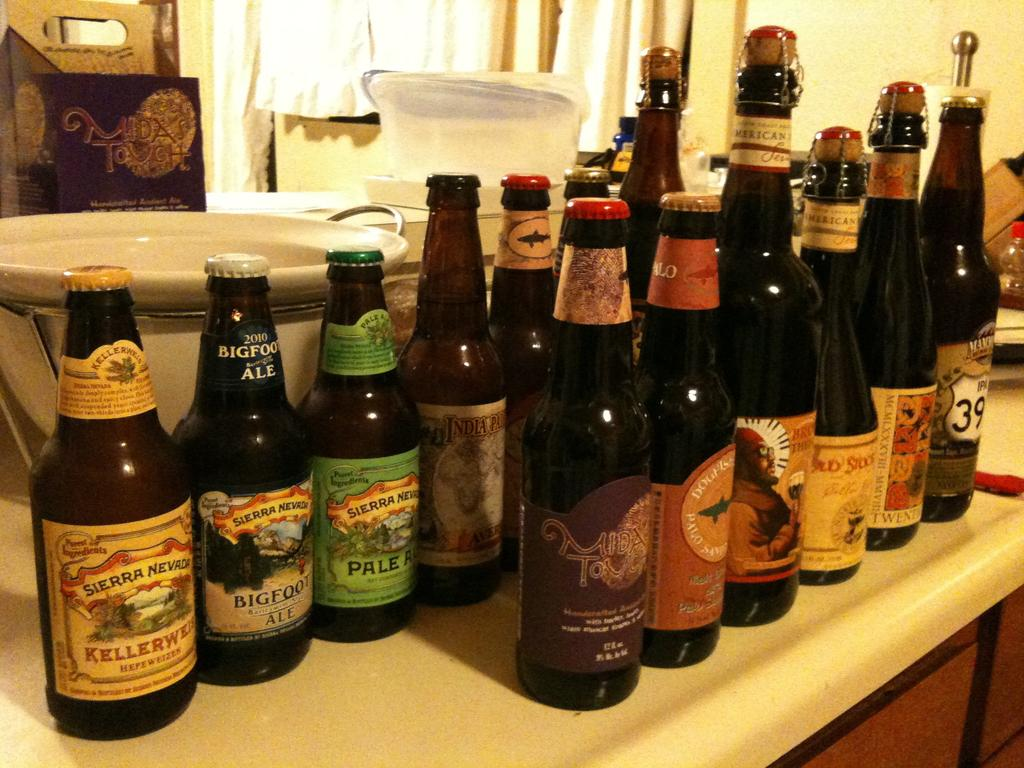<image>
Offer a succinct explanation of the picture presented. A bottle of Sierra Nevada beer sits at the end of a row of beer bottles. 